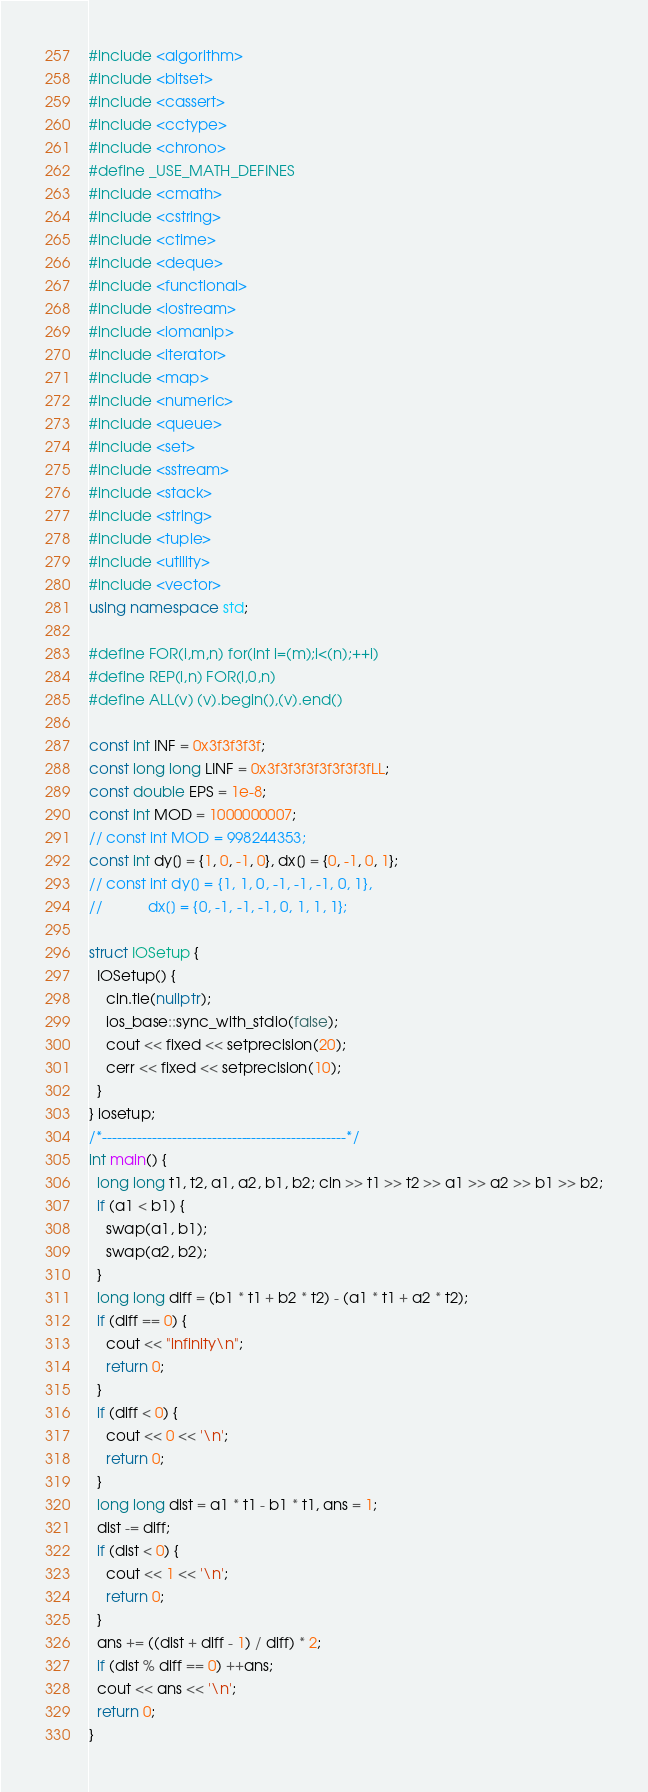<code> <loc_0><loc_0><loc_500><loc_500><_C++_>#include <algorithm>
#include <bitset>
#include <cassert>
#include <cctype>
#include <chrono>
#define _USE_MATH_DEFINES
#include <cmath>
#include <cstring>
#include <ctime>
#include <deque>
#include <functional>
#include <iostream>
#include <iomanip>
#include <iterator>
#include <map>
#include <numeric>
#include <queue>
#include <set>
#include <sstream>
#include <stack>
#include <string>
#include <tuple>
#include <utility>
#include <vector>
using namespace std;

#define FOR(i,m,n) for(int i=(m);i<(n);++i)
#define REP(i,n) FOR(i,0,n)
#define ALL(v) (v).begin(),(v).end()

const int INF = 0x3f3f3f3f;
const long long LINF = 0x3f3f3f3f3f3f3f3fLL;
const double EPS = 1e-8;
const int MOD = 1000000007;
// const int MOD = 998244353;
const int dy[] = {1, 0, -1, 0}, dx[] = {0, -1, 0, 1};
// const int dy[] = {1, 1, 0, -1, -1, -1, 0, 1},
//           dx[] = {0, -1, -1, -1, 0, 1, 1, 1};

struct IOSetup {
  IOSetup() {
    cin.tie(nullptr);
    ios_base::sync_with_stdio(false);
    cout << fixed << setprecision(20);
    cerr << fixed << setprecision(10);
  }
} iosetup;
/*-------------------------------------------------*/
int main() {
  long long t1, t2, a1, a2, b1, b2; cin >> t1 >> t2 >> a1 >> a2 >> b1 >> b2;
  if (a1 < b1) {
    swap(a1, b1);
    swap(a2, b2);
  }
  long long diff = (b1 * t1 + b2 * t2) - (a1 * t1 + a2 * t2);
  if (diff == 0) {
    cout << "infinity\n";
    return 0;
  }
  if (diff < 0) {
    cout << 0 << '\n';
    return 0;
  }
  long long dist = a1 * t1 - b1 * t1, ans = 1;
  dist -= diff;
  if (dist < 0) {
    cout << 1 << '\n';
    return 0;
  }
  ans += ((dist + diff - 1) / diff) * 2;
  if (dist % diff == 0) ++ans;
  cout << ans << '\n';
  return 0;
}
</code> 